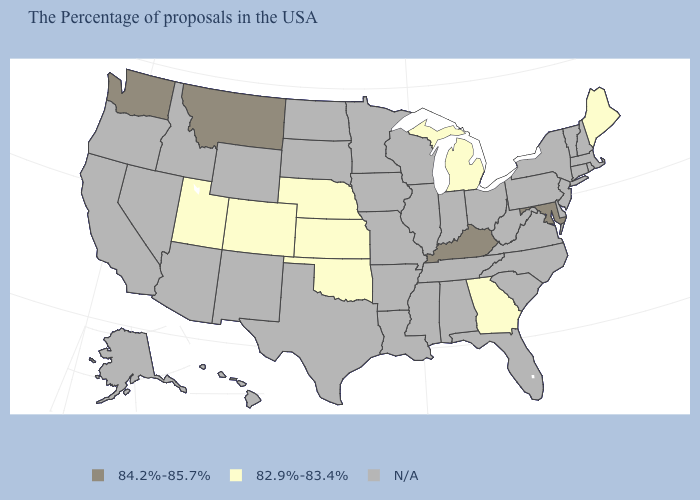Name the states that have a value in the range 82.9%-83.4%?
Short answer required. Maine, Georgia, Michigan, Kansas, Nebraska, Oklahoma, Colorado, Utah. Does the first symbol in the legend represent the smallest category?
Concise answer only. No. What is the value of Virginia?
Write a very short answer. N/A. Which states have the lowest value in the USA?
Keep it brief. Maine, Georgia, Michigan, Kansas, Nebraska, Oklahoma, Colorado, Utah. What is the highest value in the USA?
Concise answer only. 84.2%-85.7%. Does the first symbol in the legend represent the smallest category?
Write a very short answer. No. How many symbols are there in the legend?
Answer briefly. 3. What is the value of Kentucky?
Give a very brief answer. 84.2%-85.7%. What is the highest value in the West ?
Be succinct. 84.2%-85.7%. What is the value of Rhode Island?
Be succinct. N/A. Does Kansas have the highest value in the USA?
Quick response, please. No. Name the states that have a value in the range 84.2%-85.7%?
Write a very short answer. Maryland, Kentucky, Montana, Washington. Which states have the highest value in the USA?
Quick response, please. Maryland, Kentucky, Montana, Washington. Does Michigan have the lowest value in the USA?
Write a very short answer. Yes. 